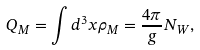Convert formula to latex. <formula><loc_0><loc_0><loc_500><loc_500>Q _ { M } = \int d ^ { 3 } x \rho _ { M } = \frac { 4 \pi } { g } N _ { W } ,</formula> 